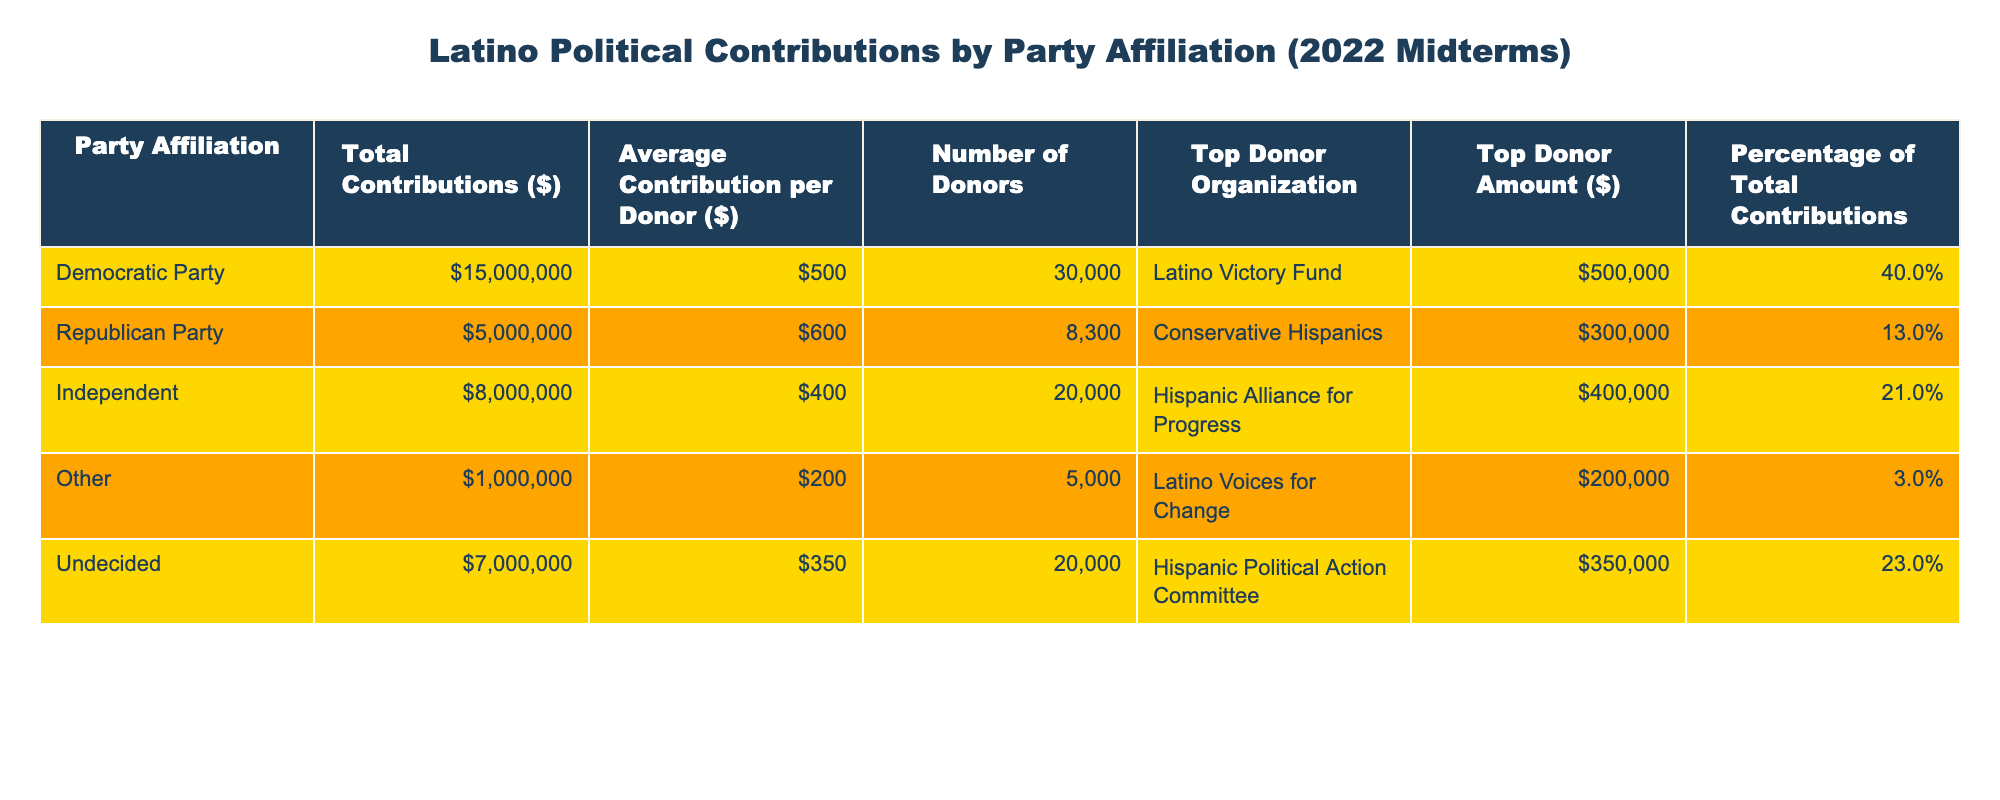What's the total contribution of the Democratic Party? The table shows that the total contributions for the Democratic Party are listed directly under the "Total Contributions ($)" column. From the data provided, it states 15,000,000 dollars.
Answer: 15,000,000 What is the average contribution per donor for the Republican Party? The average contribution per donor is listed in the corresponding row for the Republican Party under the "Average Contribution per Donor ($)" column, which is 600 dollars.
Answer: 600 Which party has the highest percentage of total contributions? To answer this, I look for the maximum value in the "Percentage of Total Contributions" column. The Democratic Party has 40%, which is higher than all other parties listed.
Answer: Democratic Party How many total donors contributed to the Independent Party? The "Number of Donors" for the Independent Party is mentioned in the table. It shows that there are 20,000 donors.
Answer: 20,000 What is the sum of the total contributions for the Republican and Independent parties? To find this, I add the total contributions of both parties: Republican Party (5,000,000) + Independent (8,000,000) = 13,000,000 dollars.
Answer: 13,000,000 Did the Undecided group contribute more than the Other group? The contribution for the Undecided group is 7,000,000 dollars, while the Other group contributed 1,000,000 dollars. Since 7,000,000 is greater than 1,000,000, the statement is true.
Answer: Yes What is the average contribution per donor across all groups? First, calculate the total contributions for all groups: 15,000,000 + 5,000,000 + 8,000,000 + 1,000,000 + 7,000,000 = 36,000,000. Then, calculate the total number of donors: 30,000 + 8,300 + 20,000 + 5,000 + 20,000 = 83,300. The average is 36,000,000 / 83,300 which is approximately 432.93 dollars.
Answer: Approximately 433 Which organization contributed the highest amount to the Democratic Party? The table shows the top donor organization for the Democratic Party listed as Latino Victory Fund, with the top donor amount noted as 500,000 dollars.
Answer: Latino Victory Fund What is the contribution of the organization identified as Hispanic Alliance for Progress? The table indicates that this organization is the top donor for the Independent Party with a contribution amount of 400,000 dollars.
Answer: 400,000 Is it true that the Other group had more donors than the Republican Party? The Other group had 5,000 donors while the Republican Party had 8,300 donors. Since 5,000 is less than 8,300, the statement is false.
Answer: No 